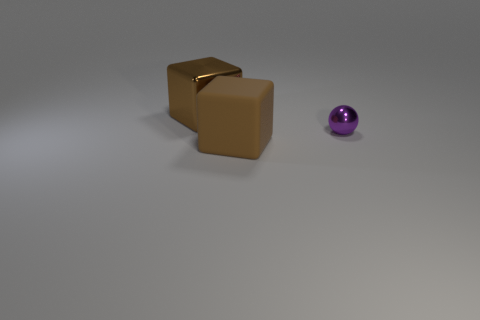Subtract all brown blocks. How many were subtracted if there are1brown blocks left? 1 Subtract 1 balls. How many balls are left? 0 Add 3 shiny objects. How many objects exist? 6 Subtract all brown blocks. How many green spheres are left? 0 Add 1 brown metallic blocks. How many brown metallic blocks are left? 2 Add 1 brown blocks. How many brown blocks exist? 3 Subtract 1 purple spheres. How many objects are left? 2 Subtract all spheres. How many objects are left? 2 Subtract all blue spheres. Subtract all red cylinders. How many spheres are left? 1 Subtract all large brown things. Subtract all small gray cylinders. How many objects are left? 1 